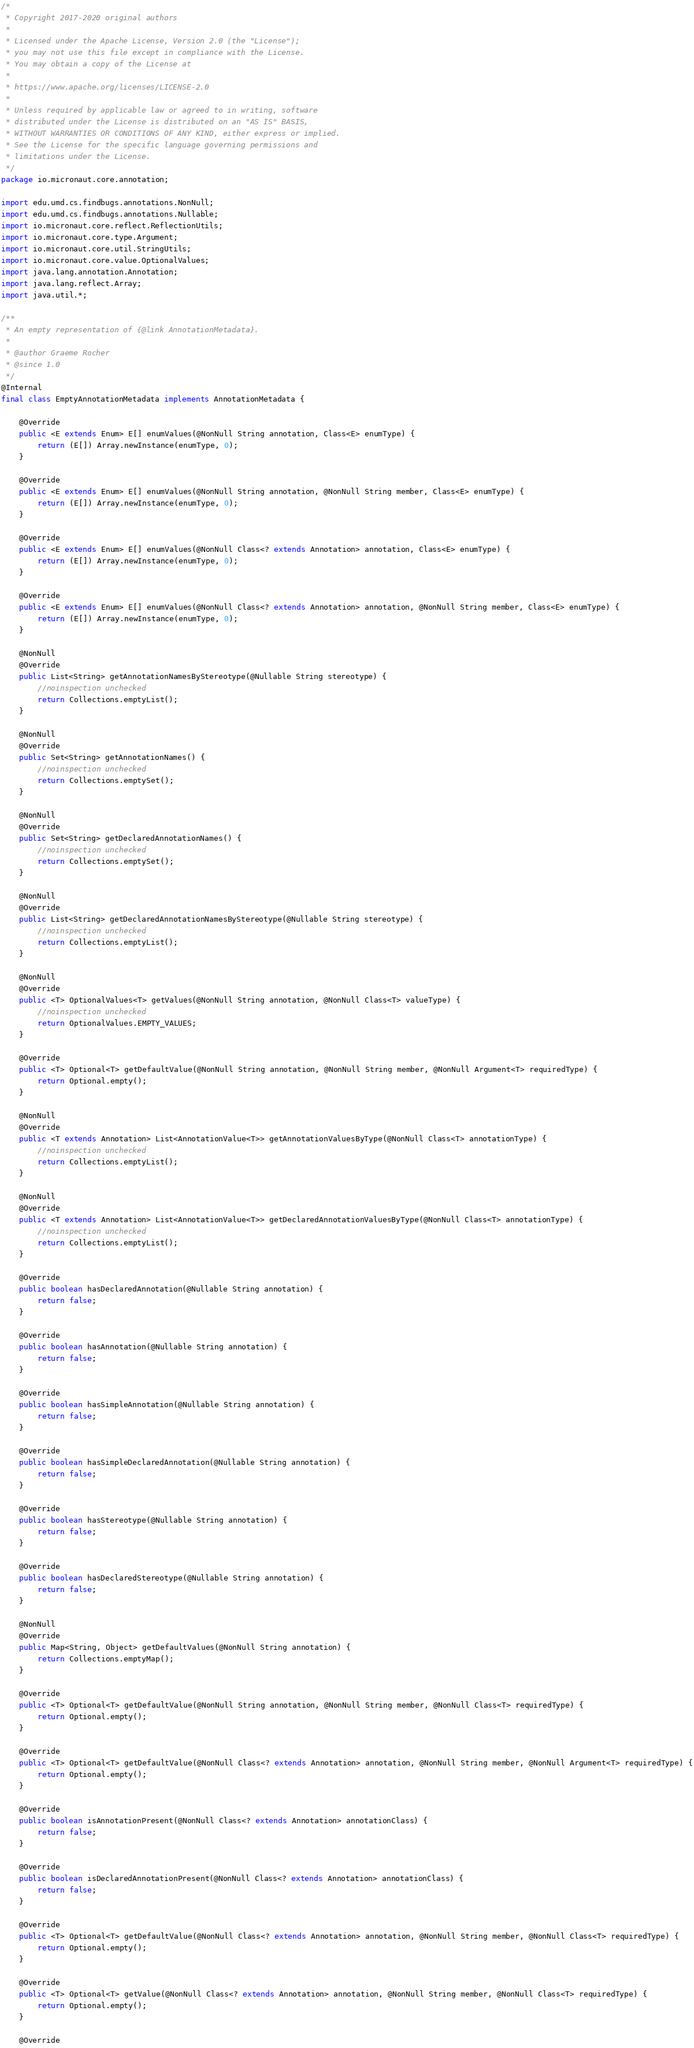<code> <loc_0><loc_0><loc_500><loc_500><_Java_>/*
 * Copyright 2017-2020 original authors
 *
 * Licensed under the Apache License, Version 2.0 (the "License");
 * you may not use this file except in compliance with the License.
 * You may obtain a copy of the License at
 *
 * https://www.apache.org/licenses/LICENSE-2.0
 *
 * Unless required by applicable law or agreed to in writing, software
 * distributed under the License is distributed on an "AS IS" BASIS,
 * WITHOUT WARRANTIES OR CONDITIONS OF ANY KIND, either express or implied.
 * See the License for the specific language governing permissions and
 * limitations under the License.
 */
package io.micronaut.core.annotation;

import edu.umd.cs.findbugs.annotations.NonNull;
import edu.umd.cs.findbugs.annotations.Nullable;
import io.micronaut.core.reflect.ReflectionUtils;
import io.micronaut.core.type.Argument;
import io.micronaut.core.util.StringUtils;
import io.micronaut.core.value.OptionalValues;
import java.lang.annotation.Annotation;
import java.lang.reflect.Array;
import java.util.*;

/**
 * An empty representation of {@link AnnotationMetadata}.
 *
 * @author Graeme Rocher
 * @since 1.0
 */
@Internal
final class EmptyAnnotationMetadata implements AnnotationMetadata {

    @Override
    public <E extends Enum> E[] enumValues(@NonNull String annotation, Class<E> enumType) {
        return (E[]) Array.newInstance(enumType, 0);
    }

    @Override
    public <E extends Enum> E[] enumValues(@NonNull String annotation, @NonNull String member, Class<E> enumType) {
        return (E[]) Array.newInstance(enumType, 0);
    }

    @Override
    public <E extends Enum> E[] enumValues(@NonNull Class<? extends Annotation> annotation, Class<E> enumType) {
        return (E[]) Array.newInstance(enumType, 0);
    }

    @Override
    public <E extends Enum> E[] enumValues(@NonNull Class<? extends Annotation> annotation, @NonNull String member, Class<E> enumType) {
        return (E[]) Array.newInstance(enumType, 0);
    }

    @NonNull
    @Override
    public List<String> getAnnotationNamesByStereotype(@Nullable String stereotype) {
        //noinspection unchecked
        return Collections.emptyList();
    }

    @NonNull
    @Override
    public Set<String> getAnnotationNames() {
        //noinspection unchecked
        return Collections.emptySet();
    }

    @NonNull
    @Override
    public Set<String> getDeclaredAnnotationNames() {
        //noinspection unchecked
        return Collections.emptySet();
    }

    @NonNull
    @Override
    public List<String> getDeclaredAnnotationNamesByStereotype(@Nullable String stereotype) {
        //noinspection unchecked
        return Collections.emptyList();
    }

    @NonNull
    @Override
    public <T> OptionalValues<T> getValues(@NonNull String annotation, @NonNull Class<T> valueType) {
        //noinspection unchecked
        return OptionalValues.EMPTY_VALUES;
    }

    @Override
    public <T> Optional<T> getDefaultValue(@NonNull String annotation, @NonNull String member, @NonNull Argument<T> requiredType) {
        return Optional.empty();
    }

    @NonNull
    @Override
    public <T extends Annotation> List<AnnotationValue<T>> getAnnotationValuesByType(@NonNull Class<T> annotationType) {
        //noinspection unchecked
        return Collections.emptyList();
    }

    @NonNull
    @Override
    public <T extends Annotation> List<AnnotationValue<T>> getDeclaredAnnotationValuesByType(@NonNull Class<T> annotationType) {
        //noinspection unchecked
        return Collections.emptyList();
    }

    @Override
    public boolean hasDeclaredAnnotation(@Nullable String annotation) {
        return false;
    }

    @Override
    public boolean hasAnnotation(@Nullable String annotation) {
        return false;
    }

    @Override
    public boolean hasSimpleAnnotation(@Nullable String annotation) {
        return false;
    }

    @Override
    public boolean hasSimpleDeclaredAnnotation(@Nullable String annotation) {
        return false;
    }

    @Override
    public boolean hasStereotype(@Nullable String annotation) {
        return false;
    }

    @Override
    public boolean hasDeclaredStereotype(@Nullable String annotation) {
        return false;
    }

    @NonNull
    @Override
    public Map<String, Object> getDefaultValues(@NonNull String annotation) {
        return Collections.emptyMap();
    }

    @Override
    public <T> Optional<T> getDefaultValue(@NonNull String annotation, @NonNull String member, @NonNull Class<T> requiredType) {
        return Optional.empty();
    }

    @Override
    public <T> Optional<T> getDefaultValue(@NonNull Class<? extends Annotation> annotation, @NonNull String member, @NonNull Argument<T> requiredType) {
        return Optional.empty();
    }

    @Override
    public boolean isAnnotationPresent(@NonNull Class<? extends Annotation> annotationClass) {
        return false;
    }

    @Override
    public boolean isDeclaredAnnotationPresent(@NonNull Class<? extends Annotation> annotationClass) {
        return false;
    }

    @Override
    public <T> Optional<T> getDefaultValue(@NonNull Class<? extends Annotation> annotation, @NonNull String member, @NonNull Class<T> requiredType) {
        return Optional.empty();
    }

    @Override
    public <T> Optional<T> getValue(@NonNull Class<? extends Annotation> annotation, @NonNull String member, @NonNull Class<T> requiredType) {
        return Optional.empty();
    }

    @Override</code> 